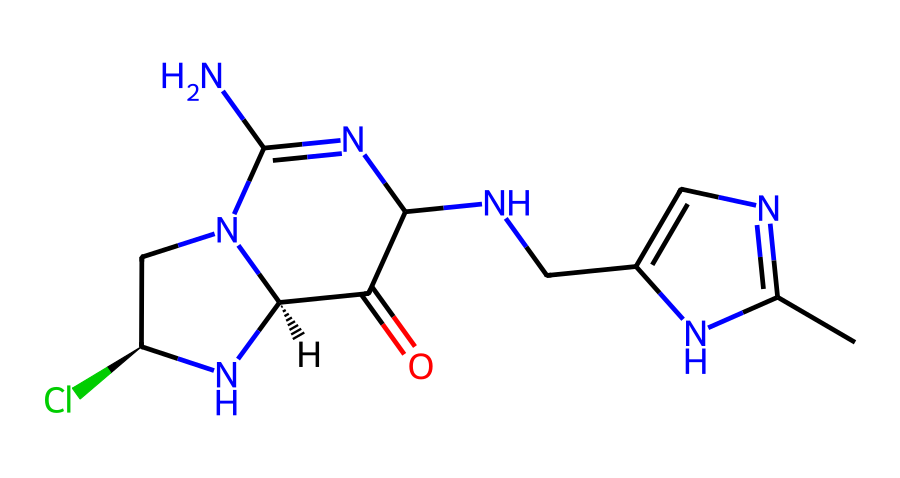What is the functional group present in this neonicotinoid? The chemical contains a N-methyl group and a carbonyl group (C=O) as part of its structure, indicating it belongs to a class of compounds that possess multiple nitrogen atoms and a characteristic carbonyl.
Answer: N-methyl and carbonyl group How many nitrogen atoms are present in this structure? By examining the SMILES representation, there are multiple instances of "N," which indicates the number of nitrogen atoms in the molecular structure. Counting each "N" gives a total of 5.
Answer: 5 What does the presence of chlorine suggest about this compound? The chlorine atom in the structure typically indicates the compound could exhibit higher reactivity and possible environmental persistence, which are common traits of pesticides.
Answer: Higher reactivity Which type of bonding is likely present within this neonicotinoid? The chemical structure suggests that there are both covalent bonds (between carbon and nitrogen) and potentially weak interactions due to the presence of the nitrogen-containing groups, which is characteristic of pesticide compounds.
Answer: Covalent bonds What type of pesticide is represented by this neonicotinoid structure? This structure shows characteristics typical of systemic insecticides that primarily target the nervous system of insects, indicating it is a neonicotinoid.
Answer: Systemic insecticide 